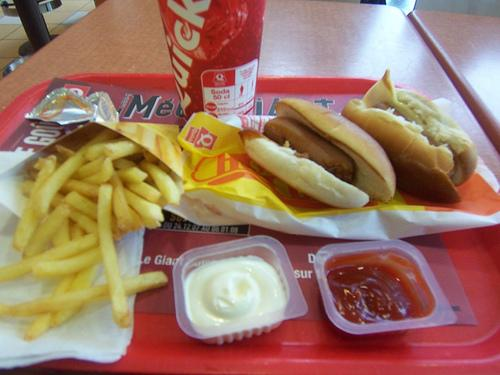What is being dipped in the red sauce?

Choices:
A) fries
B) hot dog
C) drink
D) bread fries 